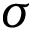<formula> <loc_0><loc_0><loc_500><loc_500>\sigma</formula> 